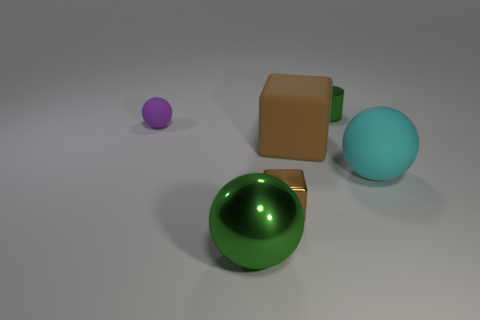Subtract all rubber balls. How many balls are left? 1 Add 4 large green spheres. How many objects exist? 10 Subtract all cylinders. How many objects are left? 5 Add 5 metal cubes. How many metal cubes are left? 6 Add 1 yellow shiny objects. How many yellow shiny objects exist? 1 Subtract 0 yellow spheres. How many objects are left? 6 Subtract all big green shiny objects. Subtract all cyan things. How many objects are left? 4 